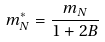<formula> <loc_0><loc_0><loc_500><loc_500>m _ { N } ^ { * } = \frac { m _ { N } } { 1 + 2 B }</formula> 